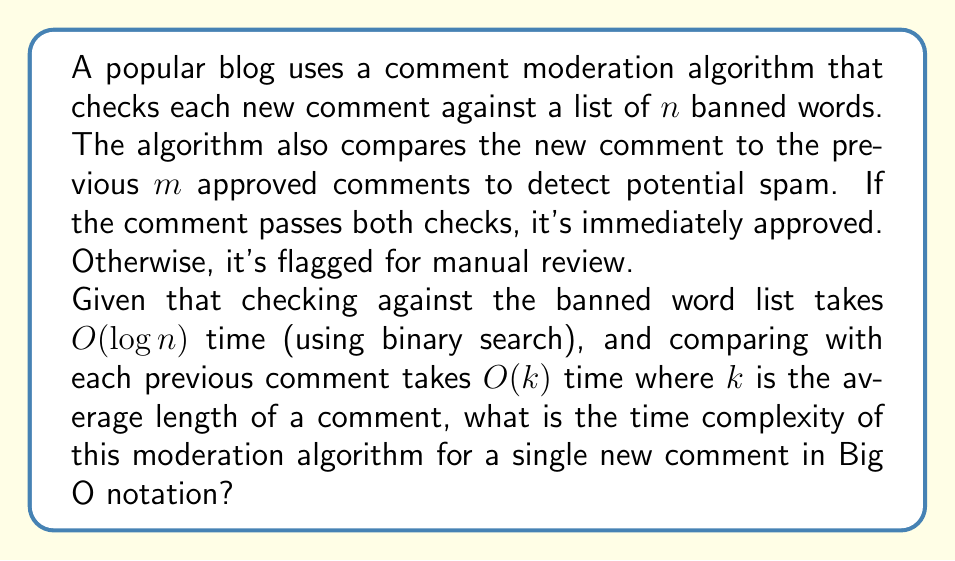Provide a solution to this math problem. Let's break down the algorithm and analyze its time complexity step by step:

1. Checking against banned words:
   - The algorithm uses binary search on the list of $n$ banned words.
   - Time complexity: $O(\log n)$

2. Comparing with previous comments:
   - The algorithm compares the new comment with $m$ previous comments.
   - Each comparison takes $O(k)$ time, where $k$ is the average comment length.
   - This step is repeated $m$ times.
   - Time complexity: $O(m \cdot k)$

3. Total time complexity:
   - The algorithm performs both steps for each new comment.
   - We add the time complexities of the two steps:
     $$O(\log n) + O(m \cdot k)$$

4. Simplifying the expression:
   - Since we're using Big O notation, we keep the term that grows faster as the input size increases.
   - $O(\log n)$ grows slower than $O(m \cdot k)$ for large values of $m$ and $k$.
   - Therefore, the dominant term is $O(m \cdot k)$.

Thus, the overall time complexity of the moderation algorithm for a single new comment is $O(m \cdot k)$.
Answer: $O(m \cdot k)$, where $m$ is the number of previous comments checked and $k$ is the average comment length. 